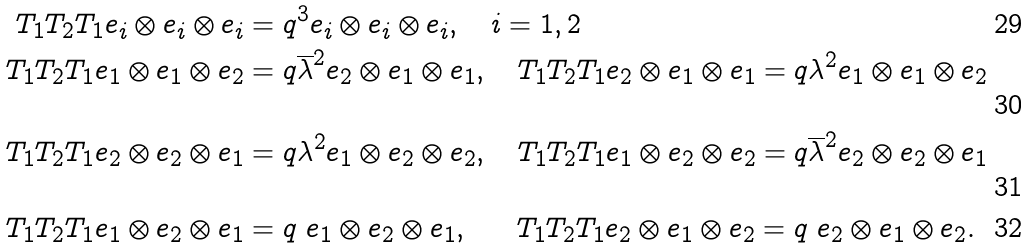<formula> <loc_0><loc_0><loc_500><loc_500>T _ { 1 } T _ { 2 } T _ { 1 } e _ { i } \otimes e _ { i } \otimes e _ { i } & = q ^ { 3 } e _ { i } \otimes e _ { i } \otimes e _ { i } , \quad i = 1 , 2 \\ T _ { 1 } T _ { 2 } T _ { 1 } e _ { 1 } \otimes e _ { 1 } \otimes e _ { 2 } & = q \overline { \lambda } ^ { 2 } e _ { 2 } \otimes e _ { 1 } \otimes e _ { 1 } , \quad T _ { 1 } T _ { 2 } T _ { 1 } e _ { 2 } \otimes e _ { 1 } \otimes e _ { 1 } = q \lambda ^ { 2 } e _ { 1 } \otimes e _ { 1 } \otimes e _ { 2 } \\ T _ { 1 } T _ { 2 } T _ { 1 } e _ { 2 } \otimes e _ { 2 } \otimes e _ { 1 } & = q \lambda ^ { 2 } e _ { 1 } \otimes e _ { 2 } \otimes e _ { 2 } , \quad T _ { 1 } T _ { 2 } T _ { 1 } e _ { 1 } \otimes e _ { 2 } \otimes e _ { 2 } = q \overline { \lambda } ^ { 2 } e _ { 2 } \otimes e _ { 2 } \otimes e _ { 1 } \\ T _ { 1 } T _ { 2 } T _ { 1 } e _ { 1 } \otimes e _ { 2 } \otimes e _ { 1 } & = q \ e _ { 1 } \otimes e _ { 2 } \otimes e _ { 1 } , \quad \ \ T _ { 1 } T _ { 2 } T _ { 1 } e _ { 2 } \otimes e _ { 1 } \otimes e _ { 2 } = q \ e _ { 2 } \otimes e _ { 1 } \otimes e _ { 2 } .</formula> 